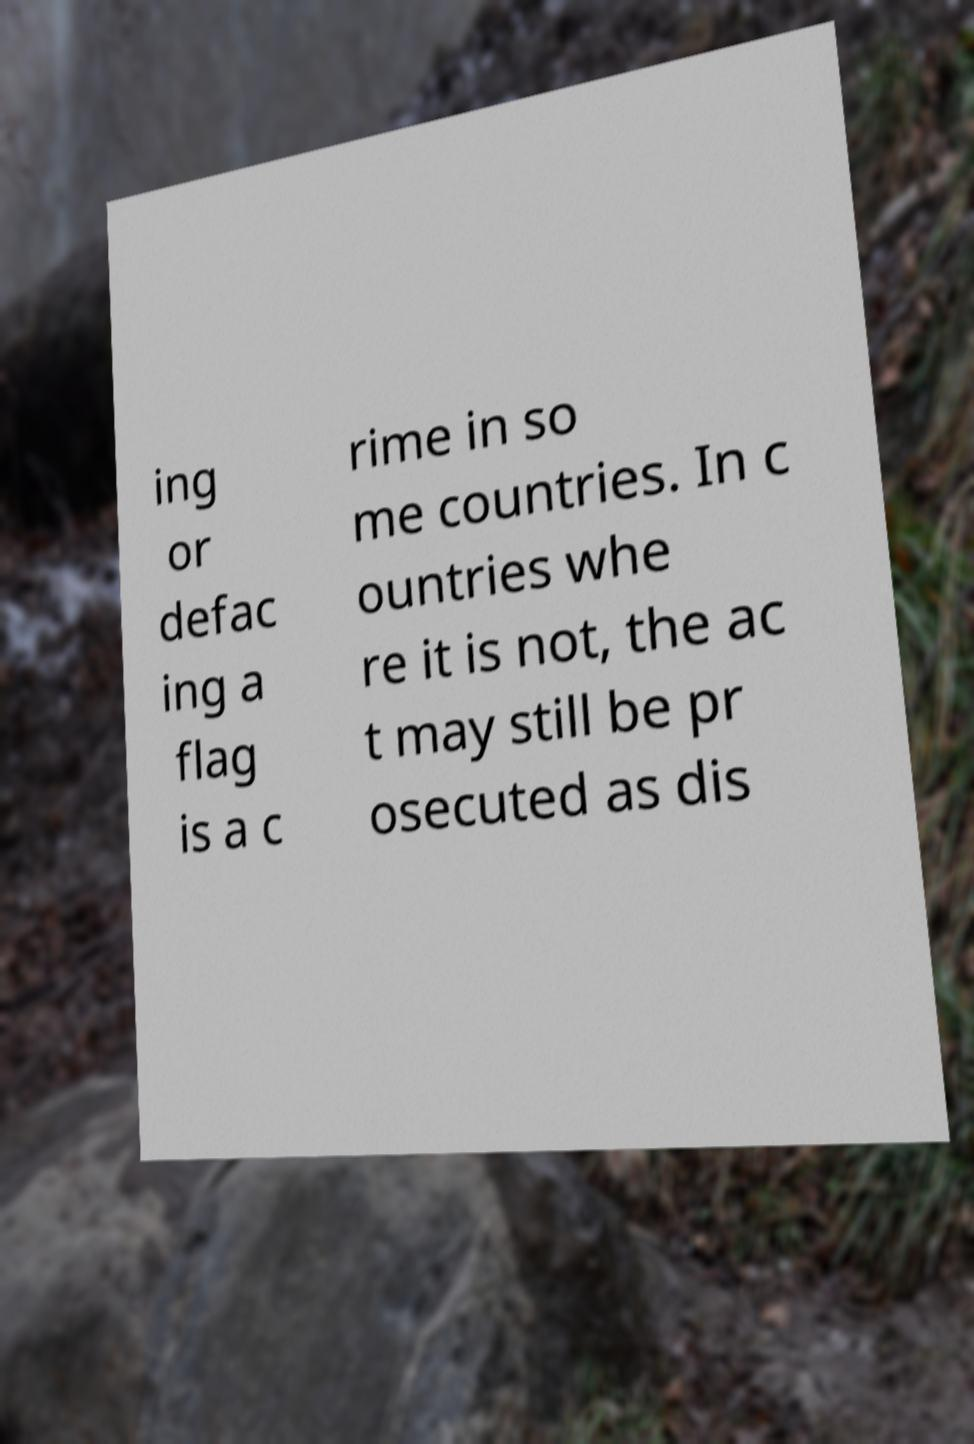For documentation purposes, I need the text within this image transcribed. Could you provide that? ing or defac ing a flag is a c rime in so me countries. In c ountries whe re it is not, the ac t may still be pr osecuted as dis 